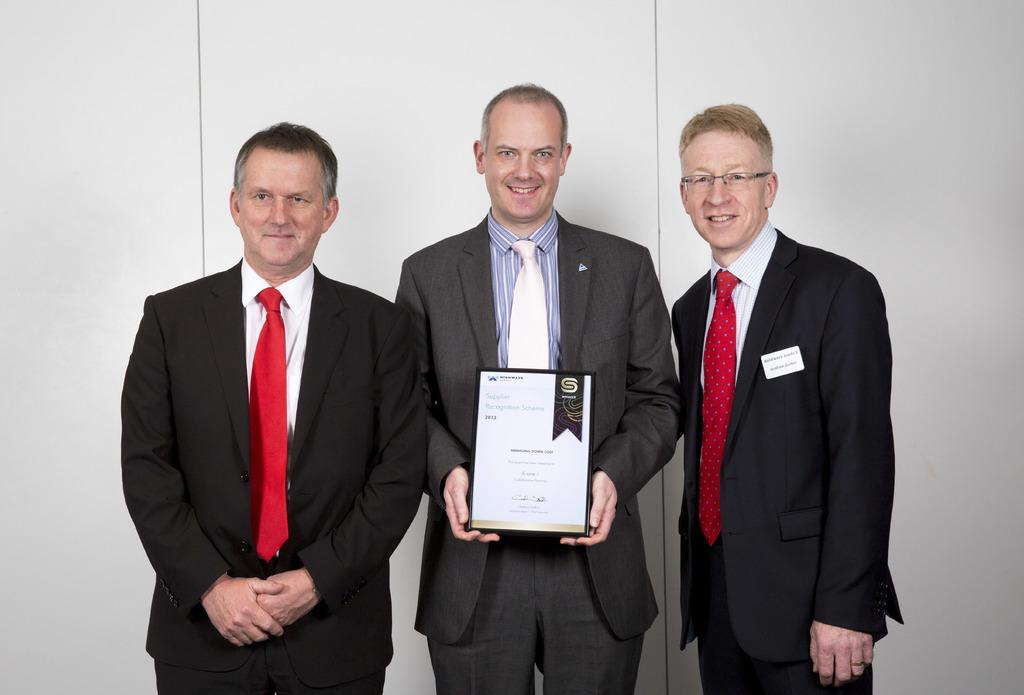What are the people in the image doing? The people in the image are standing and smiling. Can you describe what the man is holding? The man is holding a frame. What is the color of the wall behind the people? The wall behind the people is white. What type of jelly is being used to create the plot in the image? There is no jelly or plot present in the image; it features people standing and smiling, with a man holding a frame. 